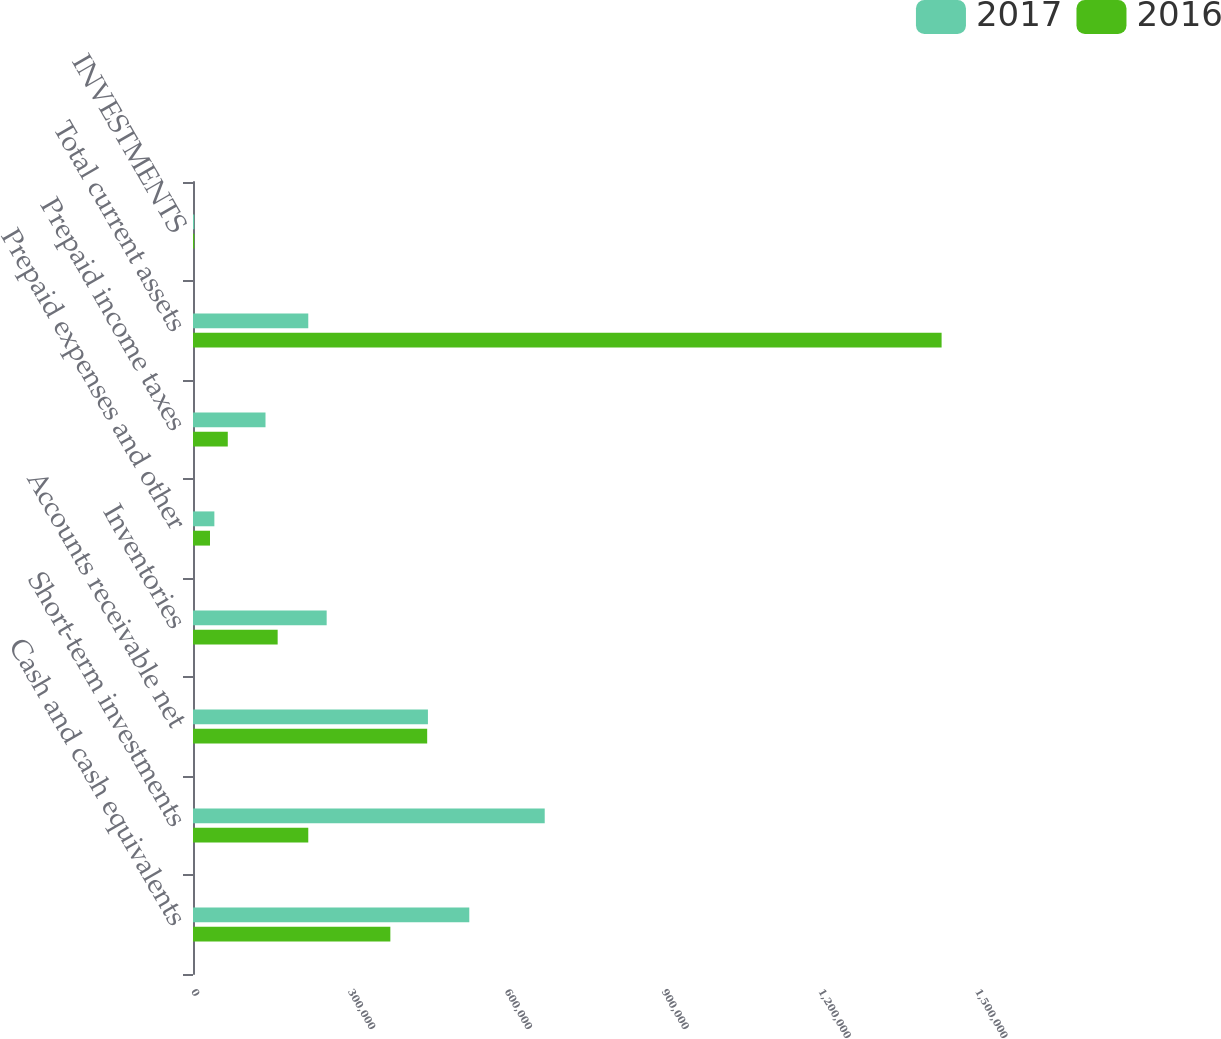<chart> <loc_0><loc_0><loc_500><loc_500><stacked_bar_chart><ecel><fcel>Cash and cash equivalents<fcel>Short-term investments<fcel>Accounts receivable net<fcel>Inventories<fcel>Prepaid expenses and other<fcel>Prepaid income taxes<fcel>Total current assets<fcel>INVESTMENTS<nl><fcel>2017<fcel>528622<fcel>672933<fcel>449476<fcel>255745<fcel>40877<fcel>138724<fcel>220554<fcel>2366<nl><fcel>2016<fcel>377582<fcel>220554<fcel>448051<fcel>161971<fcel>32562<fcel>66550<fcel>1.43227e+06<fcel>2394<nl></chart> 